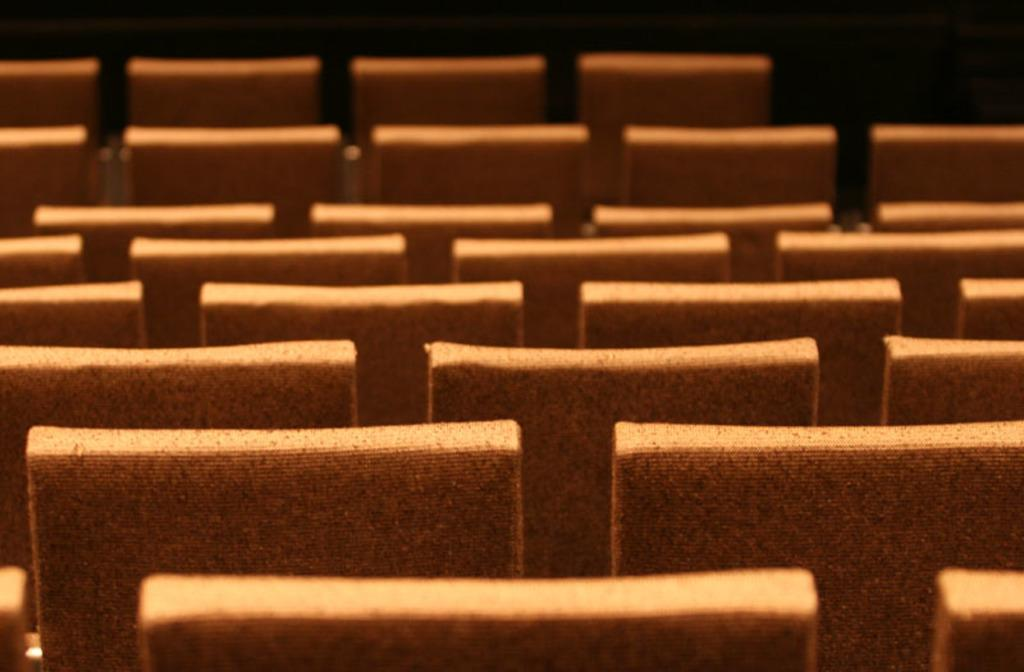What color are the chairs in the image? The chairs in the image are brown in color. How are the chairs arranged in the image? The chairs are arranged on a surface. What can be observed about the background of the image? The background of the image is dark in color. Can you see any twigs on the chairs in the image? There are no twigs visible on the chairs in the image. What type of knee injury is depicted in the image? There is no knee injury present in the image; it only features brown color chairs arranged on a surface. 